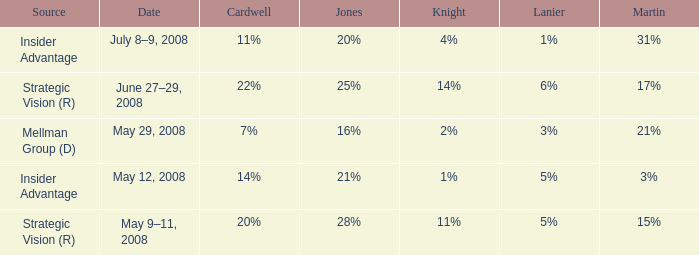Give me the full table as a dictionary. {'header': ['Source', 'Date', 'Cardwell', 'Jones', 'Knight', 'Lanier', 'Martin'], 'rows': [['Insider Advantage', 'July 8–9, 2008', '11%', '20%', '4%', '1%', '31%'], ['Strategic Vision (R)', 'June 27–29, 2008', '22%', '25%', '14%', '6%', '17%'], ['Mellman Group (D)', 'May 29, 2008', '7%', '16%', '2%', '3%', '21%'], ['Insider Advantage', 'May 12, 2008', '14%', '21%', '1%', '5%', '3%'], ['Strategic Vision (R)', 'May 9–11, 2008', '20%', '28%', '11%', '5%', '15%']]} What martin contains a lanier of 6%? 17%. 